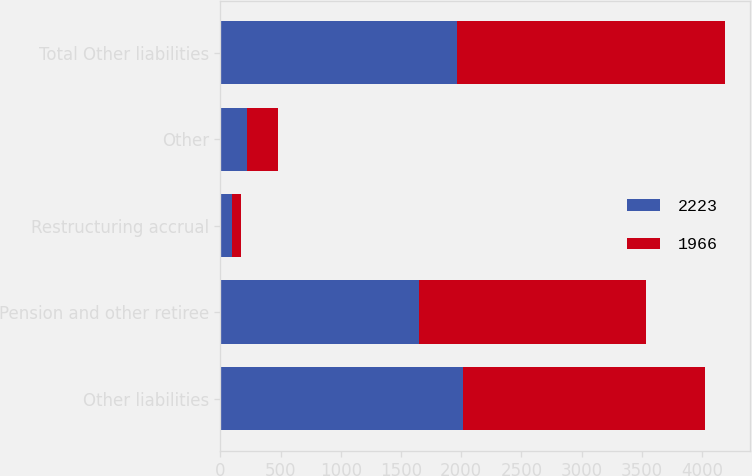<chart> <loc_0><loc_0><loc_500><loc_500><stacked_bar_chart><ecel><fcel>Other liabilities<fcel>Pension and other retiree<fcel>Restructuring accrual<fcel>Other<fcel>Total Other liabilities<nl><fcel>2223<fcel>2015<fcel>1650<fcel>96<fcel>220<fcel>1966<nl><fcel>1966<fcel>2014<fcel>1886<fcel>78<fcel>259<fcel>2223<nl></chart> 